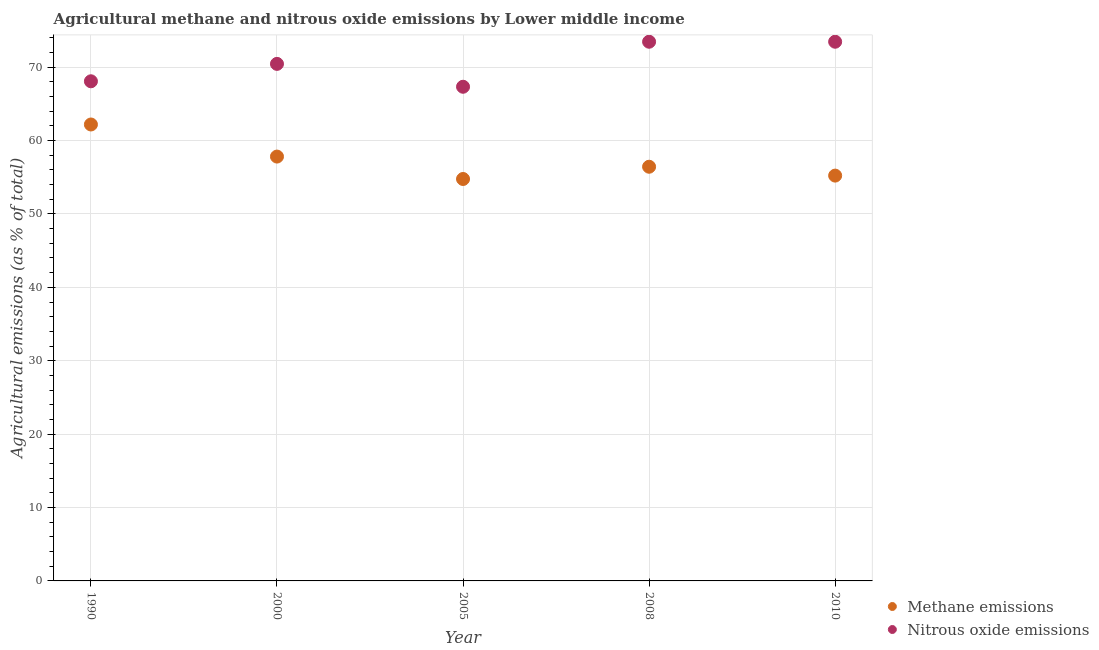How many different coloured dotlines are there?
Your answer should be very brief. 2. Is the number of dotlines equal to the number of legend labels?
Offer a terse response. Yes. What is the amount of methane emissions in 1990?
Keep it short and to the point. 62.18. Across all years, what is the maximum amount of nitrous oxide emissions?
Your answer should be compact. 73.46. Across all years, what is the minimum amount of methane emissions?
Your response must be concise. 54.76. In which year was the amount of nitrous oxide emissions maximum?
Give a very brief answer. 2010. What is the total amount of methane emissions in the graph?
Your response must be concise. 286.4. What is the difference between the amount of nitrous oxide emissions in 1990 and that in 2000?
Give a very brief answer. -2.37. What is the difference between the amount of nitrous oxide emissions in 2010 and the amount of methane emissions in 2005?
Provide a short and direct response. 18.7. What is the average amount of methane emissions per year?
Your response must be concise. 57.28. In the year 2005, what is the difference between the amount of methane emissions and amount of nitrous oxide emissions?
Keep it short and to the point. -12.56. What is the ratio of the amount of nitrous oxide emissions in 1990 to that in 2000?
Provide a short and direct response. 0.97. Is the difference between the amount of methane emissions in 1990 and 2010 greater than the difference between the amount of nitrous oxide emissions in 1990 and 2010?
Your answer should be compact. Yes. What is the difference between the highest and the second highest amount of methane emissions?
Your answer should be compact. 4.37. What is the difference between the highest and the lowest amount of methane emissions?
Provide a succinct answer. 7.42. Is the sum of the amount of methane emissions in 1990 and 2008 greater than the maximum amount of nitrous oxide emissions across all years?
Keep it short and to the point. Yes. Does the amount of methane emissions monotonically increase over the years?
Provide a succinct answer. No. How many dotlines are there?
Make the answer very short. 2. How many years are there in the graph?
Provide a short and direct response. 5. Does the graph contain grids?
Keep it short and to the point. Yes. Where does the legend appear in the graph?
Provide a succinct answer. Bottom right. What is the title of the graph?
Provide a short and direct response. Agricultural methane and nitrous oxide emissions by Lower middle income. What is the label or title of the X-axis?
Your response must be concise. Year. What is the label or title of the Y-axis?
Your answer should be very brief. Agricultural emissions (as % of total). What is the Agricultural emissions (as % of total) of Methane emissions in 1990?
Ensure brevity in your answer.  62.18. What is the Agricultural emissions (as % of total) of Nitrous oxide emissions in 1990?
Make the answer very short. 68.07. What is the Agricultural emissions (as % of total) in Methane emissions in 2000?
Offer a very short reply. 57.81. What is the Agricultural emissions (as % of total) in Nitrous oxide emissions in 2000?
Provide a succinct answer. 70.44. What is the Agricultural emissions (as % of total) of Methane emissions in 2005?
Offer a very short reply. 54.76. What is the Agricultural emissions (as % of total) of Nitrous oxide emissions in 2005?
Your response must be concise. 67.32. What is the Agricultural emissions (as % of total) of Methane emissions in 2008?
Give a very brief answer. 56.43. What is the Agricultural emissions (as % of total) of Nitrous oxide emissions in 2008?
Provide a succinct answer. 73.46. What is the Agricultural emissions (as % of total) in Methane emissions in 2010?
Keep it short and to the point. 55.22. What is the Agricultural emissions (as % of total) in Nitrous oxide emissions in 2010?
Give a very brief answer. 73.46. Across all years, what is the maximum Agricultural emissions (as % of total) in Methane emissions?
Your answer should be compact. 62.18. Across all years, what is the maximum Agricultural emissions (as % of total) of Nitrous oxide emissions?
Offer a very short reply. 73.46. Across all years, what is the minimum Agricultural emissions (as % of total) of Methane emissions?
Offer a terse response. 54.76. Across all years, what is the minimum Agricultural emissions (as % of total) in Nitrous oxide emissions?
Offer a very short reply. 67.32. What is the total Agricultural emissions (as % of total) of Methane emissions in the graph?
Provide a succinct answer. 286.4. What is the total Agricultural emissions (as % of total) of Nitrous oxide emissions in the graph?
Provide a short and direct response. 352.75. What is the difference between the Agricultural emissions (as % of total) in Methane emissions in 1990 and that in 2000?
Your response must be concise. 4.37. What is the difference between the Agricultural emissions (as % of total) of Nitrous oxide emissions in 1990 and that in 2000?
Provide a short and direct response. -2.37. What is the difference between the Agricultural emissions (as % of total) of Methane emissions in 1990 and that in 2005?
Your response must be concise. 7.42. What is the difference between the Agricultural emissions (as % of total) of Nitrous oxide emissions in 1990 and that in 2005?
Give a very brief answer. 0.75. What is the difference between the Agricultural emissions (as % of total) of Methane emissions in 1990 and that in 2008?
Offer a very short reply. 5.76. What is the difference between the Agricultural emissions (as % of total) in Nitrous oxide emissions in 1990 and that in 2008?
Your answer should be compact. -5.39. What is the difference between the Agricultural emissions (as % of total) of Methane emissions in 1990 and that in 2010?
Provide a short and direct response. 6.96. What is the difference between the Agricultural emissions (as % of total) in Nitrous oxide emissions in 1990 and that in 2010?
Make the answer very short. -5.39. What is the difference between the Agricultural emissions (as % of total) in Methane emissions in 2000 and that in 2005?
Make the answer very short. 3.05. What is the difference between the Agricultural emissions (as % of total) in Nitrous oxide emissions in 2000 and that in 2005?
Provide a short and direct response. 3.12. What is the difference between the Agricultural emissions (as % of total) in Methane emissions in 2000 and that in 2008?
Your response must be concise. 1.39. What is the difference between the Agricultural emissions (as % of total) of Nitrous oxide emissions in 2000 and that in 2008?
Keep it short and to the point. -3.02. What is the difference between the Agricultural emissions (as % of total) of Methane emissions in 2000 and that in 2010?
Your response must be concise. 2.59. What is the difference between the Agricultural emissions (as % of total) of Nitrous oxide emissions in 2000 and that in 2010?
Provide a short and direct response. -3.02. What is the difference between the Agricultural emissions (as % of total) of Methane emissions in 2005 and that in 2008?
Ensure brevity in your answer.  -1.67. What is the difference between the Agricultural emissions (as % of total) of Nitrous oxide emissions in 2005 and that in 2008?
Your response must be concise. -6.13. What is the difference between the Agricultural emissions (as % of total) in Methane emissions in 2005 and that in 2010?
Make the answer very short. -0.46. What is the difference between the Agricultural emissions (as % of total) of Nitrous oxide emissions in 2005 and that in 2010?
Your answer should be very brief. -6.13. What is the difference between the Agricultural emissions (as % of total) in Methane emissions in 2008 and that in 2010?
Give a very brief answer. 1.21. What is the difference between the Agricultural emissions (as % of total) in Nitrous oxide emissions in 2008 and that in 2010?
Your response must be concise. -0. What is the difference between the Agricultural emissions (as % of total) in Methane emissions in 1990 and the Agricultural emissions (as % of total) in Nitrous oxide emissions in 2000?
Keep it short and to the point. -8.26. What is the difference between the Agricultural emissions (as % of total) of Methane emissions in 1990 and the Agricultural emissions (as % of total) of Nitrous oxide emissions in 2005?
Give a very brief answer. -5.14. What is the difference between the Agricultural emissions (as % of total) of Methane emissions in 1990 and the Agricultural emissions (as % of total) of Nitrous oxide emissions in 2008?
Your response must be concise. -11.27. What is the difference between the Agricultural emissions (as % of total) in Methane emissions in 1990 and the Agricultural emissions (as % of total) in Nitrous oxide emissions in 2010?
Make the answer very short. -11.27. What is the difference between the Agricultural emissions (as % of total) in Methane emissions in 2000 and the Agricultural emissions (as % of total) in Nitrous oxide emissions in 2005?
Your response must be concise. -9.51. What is the difference between the Agricultural emissions (as % of total) in Methane emissions in 2000 and the Agricultural emissions (as % of total) in Nitrous oxide emissions in 2008?
Ensure brevity in your answer.  -15.64. What is the difference between the Agricultural emissions (as % of total) of Methane emissions in 2000 and the Agricultural emissions (as % of total) of Nitrous oxide emissions in 2010?
Your answer should be very brief. -15.65. What is the difference between the Agricultural emissions (as % of total) of Methane emissions in 2005 and the Agricultural emissions (as % of total) of Nitrous oxide emissions in 2008?
Offer a terse response. -18.7. What is the difference between the Agricultural emissions (as % of total) in Methane emissions in 2005 and the Agricultural emissions (as % of total) in Nitrous oxide emissions in 2010?
Give a very brief answer. -18.7. What is the difference between the Agricultural emissions (as % of total) in Methane emissions in 2008 and the Agricultural emissions (as % of total) in Nitrous oxide emissions in 2010?
Offer a terse response. -17.03. What is the average Agricultural emissions (as % of total) in Methane emissions per year?
Make the answer very short. 57.28. What is the average Agricultural emissions (as % of total) of Nitrous oxide emissions per year?
Your answer should be very brief. 70.55. In the year 1990, what is the difference between the Agricultural emissions (as % of total) in Methane emissions and Agricultural emissions (as % of total) in Nitrous oxide emissions?
Make the answer very short. -5.89. In the year 2000, what is the difference between the Agricultural emissions (as % of total) of Methane emissions and Agricultural emissions (as % of total) of Nitrous oxide emissions?
Keep it short and to the point. -12.63. In the year 2005, what is the difference between the Agricultural emissions (as % of total) in Methane emissions and Agricultural emissions (as % of total) in Nitrous oxide emissions?
Make the answer very short. -12.56. In the year 2008, what is the difference between the Agricultural emissions (as % of total) of Methane emissions and Agricultural emissions (as % of total) of Nitrous oxide emissions?
Offer a very short reply. -17.03. In the year 2010, what is the difference between the Agricultural emissions (as % of total) of Methane emissions and Agricultural emissions (as % of total) of Nitrous oxide emissions?
Give a very brief answer. -18.24. What is the ratio of the Agricultural emissions (as % of total) in Methane emissions in 1990 to that in 2000?
Provide a succinct answer. 1.08. What is the ratio of the Agricultural emissions (as % of total) of Nitrous oxide emissions in 1990 to that in 2000?
Offer a terse response. 0.97. What is the ratio of the Agricultural emissions (as % of total) in Methane emissions in 1990 to that in 2005?
Provide a short and direct response. 1.14. What is the ratio of the Agricultural emissions (as % of total) of Nitrous oxide emissions in 1990 to that in 2005?
Ensure brevity in your answer.  1.01. What is the ratio of the Agricultural emissions (as % of total) of Methane emissions in 1990 to that in 2008?
Your answer should be very brief. 1.1. What is the ratio of the Agricultural emissions (as % of total) in Nitrous oxide emissions in 1990 to that in 2008?
Your answer should be compact. 0.93. What is the ratio of the Agricultural emissions (as % of total) in Methane emissions in 1990 to that in 2010?
Give a very brief answer. 1.13. What is the ratio of the Agricultural emissions (as % of total) of Nitrous oxide emissions in 1990 to that in 2010?
Offer a terse response. 0.93. What is the ratio of the Agricultural emissions (as % of total) of Methane emissions in 2000 to that in 2005?
Keep it short and to the point. 1.06. What is the ratio of the Agricultural emissions (as % of total) in Nitrous oxide emissions in 2000 to that in 2005?
Your answer should be very brief. 1.05. What is the ratio of the Agricultural emissions (as % of total) of Methane emissions in 2000 to that in 2008?
Ensure brevity in your answer.  1.02. What is the ratio of the Agricultural emissions (as % of total) in Nitrous oxide emissions in 2000 to that in 2008?
Offer a very short reply. 0.96. What is the ratio of the Agricultural emissions (as % of total) of Methane emissions in 2000 to that in 2010?
Ensure brevity in your answer.  1.05. What is the ratio of the Agricultural emissions (as % of total) in Nitrous oxide emissions in 2000 to that in 2010?
Offer a terse response. 0.96. What is the ratio of the Agricultural emissions (as % of total) of Methane emissions in 2005 to that in 2008?
Ensure brevity in your answer.  0.97. What is the ratio of the Agricultural emissions (as % of total) in Nitrous oxide emissions in 2005 to that in 2008?
Your answer should be compact. 0.92. What is the ratio of the Agricultural emissions (as % of total) in Methane emissions in 2005 to that in 2010?
Keep it short and to the point. 0.99. What is the ratio of the Agricultural emissions (as % of total) in Nitrous oxide emissions in 2005 to that in 2010?
Your response must be concise. 0.92. What is the ratio of the Agricultural emissions (as % of total) in Methane emissions in 2008 to that in 2010?
Your response must be concise. 1.02. What is the ratio of the Agricultural emissions (as % of total) in Nitrous oxide emissions in 2008 to that in 2010?
Give a very brief answer. 1. What is the difference between the highest and the second highest Agricultural emissions (as % of total) of Methane emissions?
Your answer should be very brief. 4.37. What is the difference between the highest and the second highest Agricultural emissions (as % of total) in Nitrous oxide emissions?
Provide a short and direct response. 0. What is the difference between the highest and the lowest Agricultural emissions (as % of total) of Methane emissions?
Ensure brevity in your answer.  7.42. What is the difference between the highest and the lowest Agricultural emissions (as % of total) in Nitrous oxide emissions?
Provide a succinct answer. 6.13. 